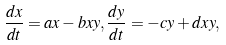Convert formula to latex. <formula><loc_0><loc_0><loc_500><loc_500>\frac { d x } { d t } = a x - b x y , \frac { d y } { d t } = - c y + d x y ,</formula> 